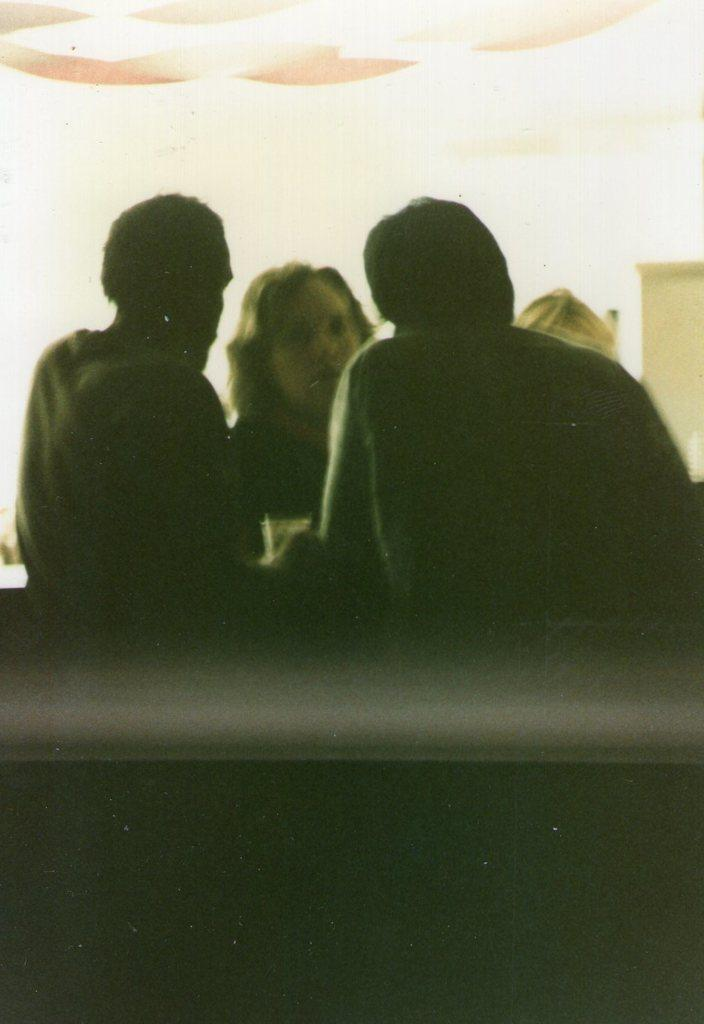What are the people in the image doing? The people in the image are standing near a desk and talking. What can be seen in the background of the image? There is a wall with a door in the background. What type of lighting is present in the image? There is a light on the ceiling. Where is the pickle located in the image? There is no pickle present in the image. What type of chair is visible in the image? There is no chair visible in the image. 